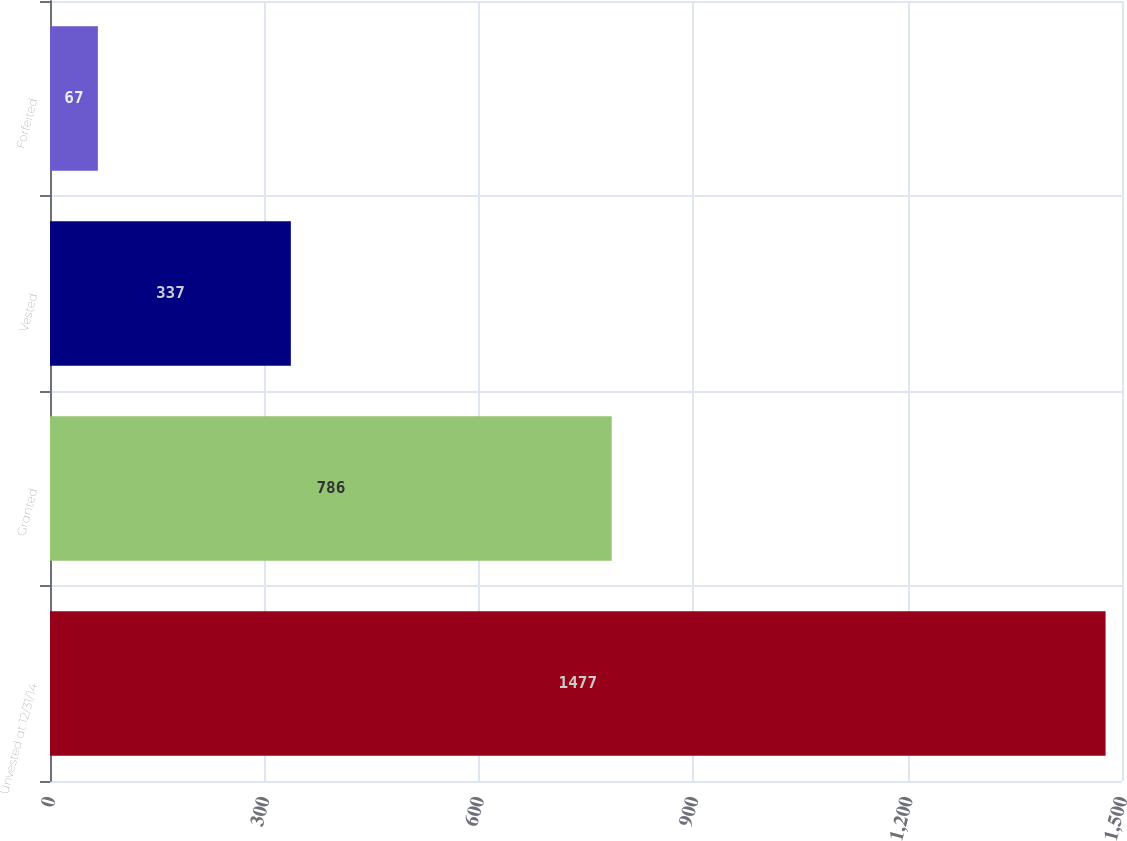Convert chart. <chart><loc_0><loc_0><loc_500><loc_500><bar_chart><fcel>Unvested at 12/31/14<fcel>Granted<fcel>Vested<fcel>Forfeited<nl><fcel>1477<fcel>786<fcel>337<fcel>67<nl></chart> 